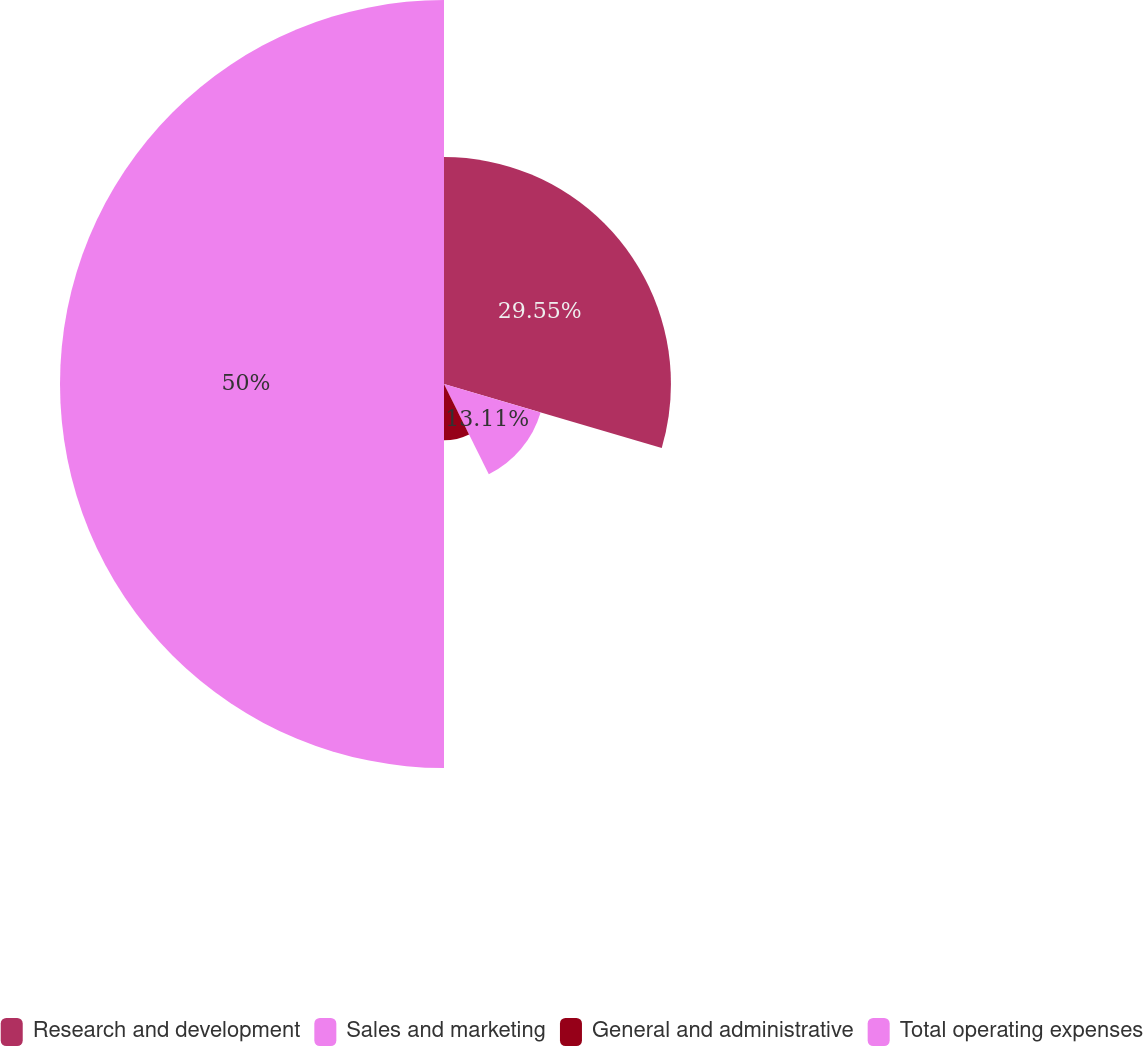Convert chart. <chart><loc_0><loc_0><loc_500><loc_500><pie_chart><fcel>Research and development<fcel>Sales and marketing<fcel>General and administrative<fcel>Total operating expenses<nl><fcel>29.55%<fcel>13.11%<fcel>7.34%<fcel>50.0%<nl></chart> 